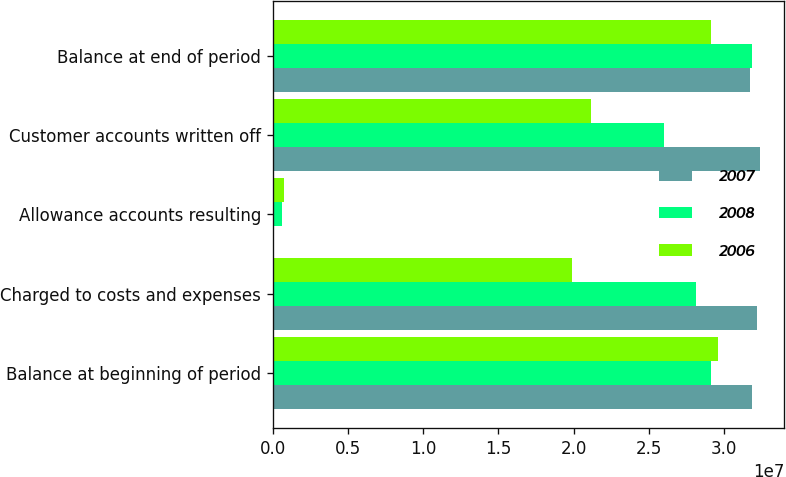<chart> <loc_0><loc_0><loc_500><loc_500><stacked_bar_chart><ecel><fcel>Balance at beginning of period<fcel>Charged to costs and expenses<fcel>Allowance accounts resulting<fcel>Customer accounts written off<fcel>Balance at end of period<nl><fcel>2007<fcel>3.1841e+07<fcel>3.2185e+07<fcel>71000<fcel>3.2367e+07<fcel>3.173e+07<nl><fcel>2008<fcel>2.91e+07<fcel>2.8156e+07<fcel>595000<fcel>2.601e+07<fcel>3.1841e+07<nl><fcel>2006<fcel>2.9604e+07<fcel>1.9895e+07<fcel>729000<fcel>2.1128e+07<fcel>2.91e+07<nl></chart> 